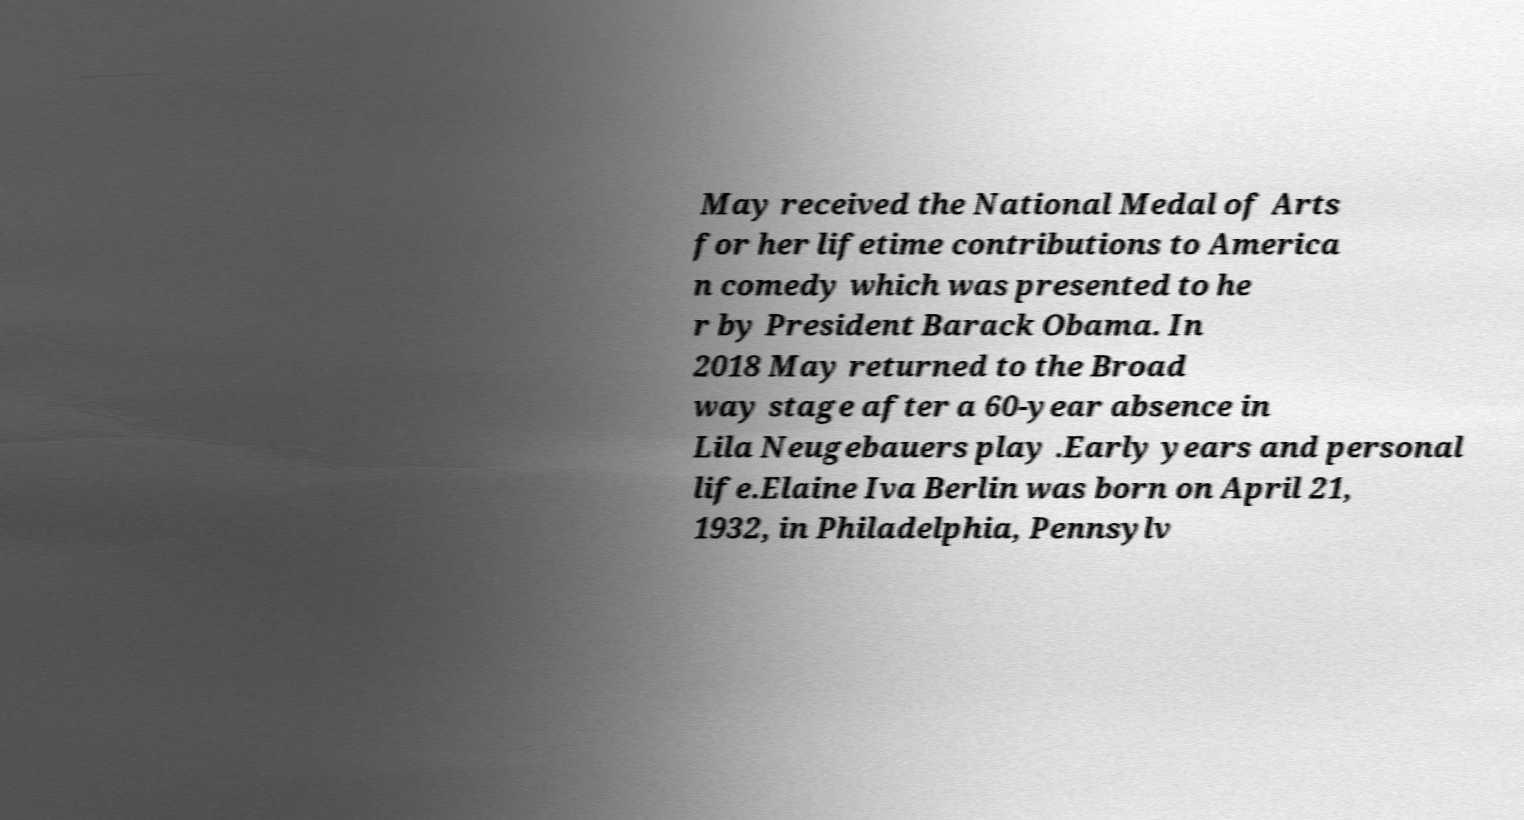Can you read and provide the text displayed in the image?This photo seems to have some interesting text. Can you extract and type it out for me? May received the National Medal of Arts for her lifetime contributions to America n comedy which was presented to he r by President Barack Obama. In 2018 May returned to the Broad way stage after a 60-year absence in Lila Neugebauers play .Early years and personal life.Elaine Iva Berlin was born on April 21, 1932, in Philadelphia, Pennsylv 